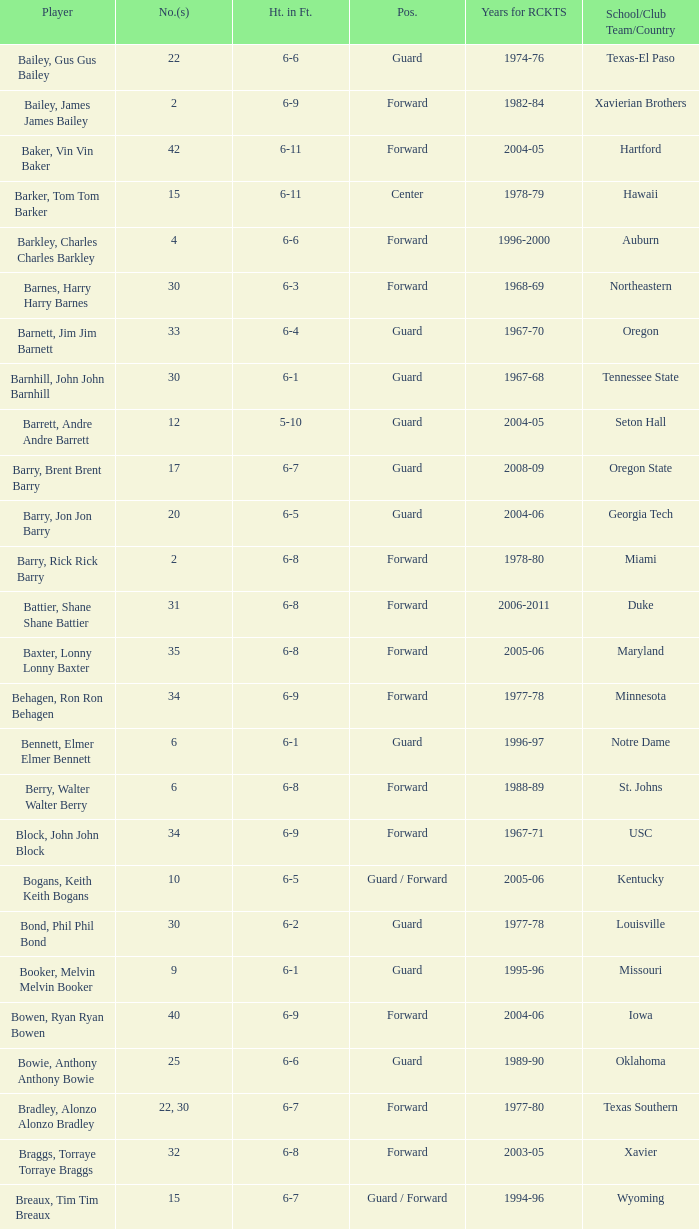What is the height of the player who attended Hartford? 6-11. 